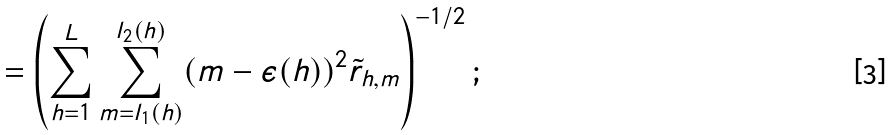<formula> <loc_0><loc_0><loc_500><loc_500>= \left ( \sum _ { h = 1 } ^ { L } \sum _ { m = l _ { 1 } ( h ) } ^ { l _ { 2 } ( h ) } ( m - \epsilon ( h ) ) ^ { 2 } \tilde { r } _ { h , m } \right ) ^ { - 1 / 2 } ;</formula> 